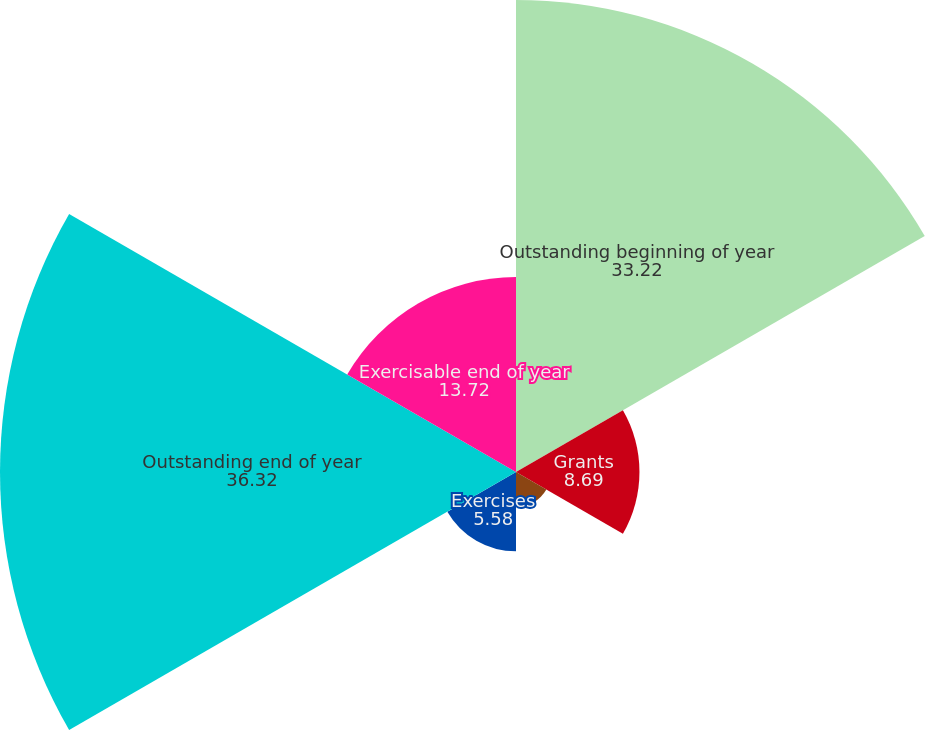<chart> <loc_0><loc_0><loc_500><loc_500><pie_chart><fcel>Outstanding beginning of year<fcel>Grants<fcel>Terminations<fcel>Exercises<fcel>Outstanding end of year<fcel>Exercisable end of year<nl><fcel>33.22%<fcel>8.69%<fcel>2.47%<fcel>5.58%<fcel>36.32%<fcel>13.72%<nl></chart> 